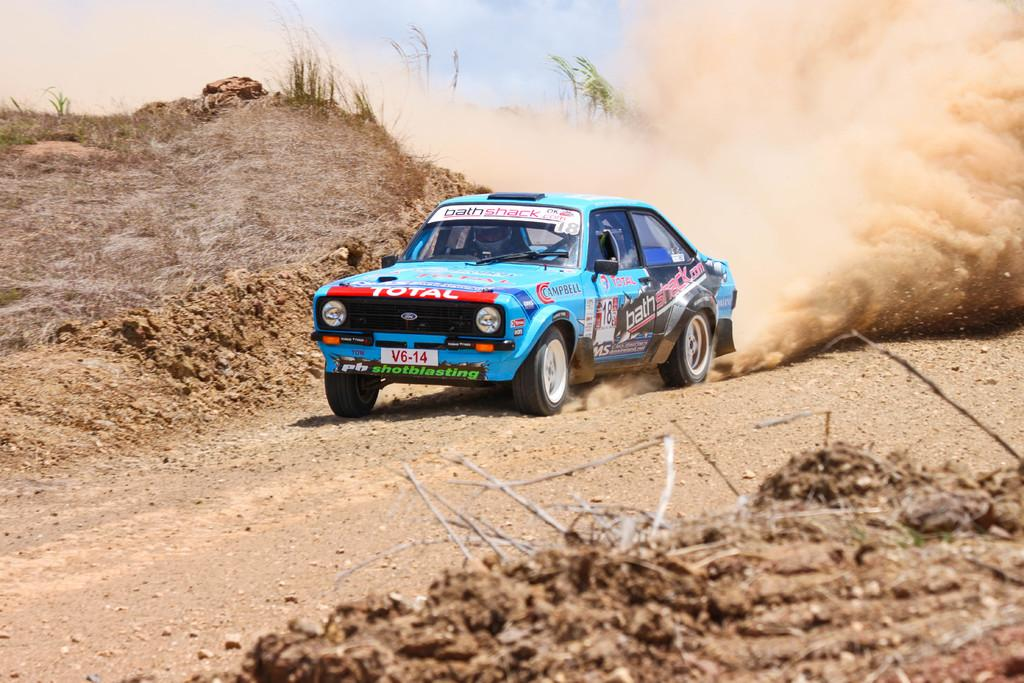What is on the ground in the image? There is a car on the ground in the image. Who or what is inside the car? A person is inside the car. What type of vegetation can be seen in the image? There is grass visible in the image. What is visible in the background of the image? The sky is visible in the background of the image. What can be seen in the sky? Clouds are present in the sky. How many boats are visible in the image? There are no boats present in the image. 